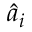<formula> <loc_0><loc_0><loc_500><loc_500>\hat { a } _ { i }</formula> 